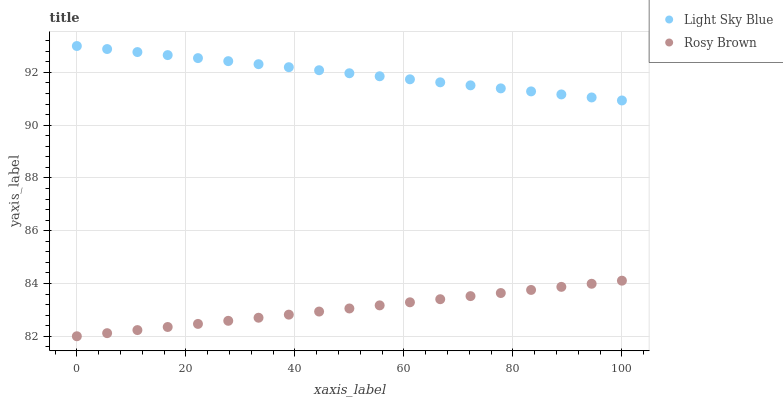Does Rosy Brown have the minimum area under the curve?
Answer yes or no. Yes. Does Light Sky Blue have the maximum area under the curve?
Answer yes or no. Yes. Does Light Sky Blue have the minimum area under the curve?
Answer yes or no. No. Is Light Sky Blue the smoothest?
Answer yes or no. Yes. Is Rosy Brown the roughest?
Answer yes or no. Yes. Is Light Sky Blue the roughest?
Answer yes or no. No. Does Rosy Brown have the lowest value?
Answer yes or no. Yes. Does Light Sky Blue have the lowest value?
Answer yes or no. No. Does Light Sky Blue have the highest value?
Answer yes or no. Yes. Is Rosy Brown less than Light Sky Blue?
Answer yes or no. Yes. Is Light Sky Blue greater than Rosy Brown?
Answer yes or no. Yes. Does Rosy Brown intersect Light Sky Blue?
Answer yes or no. No. 